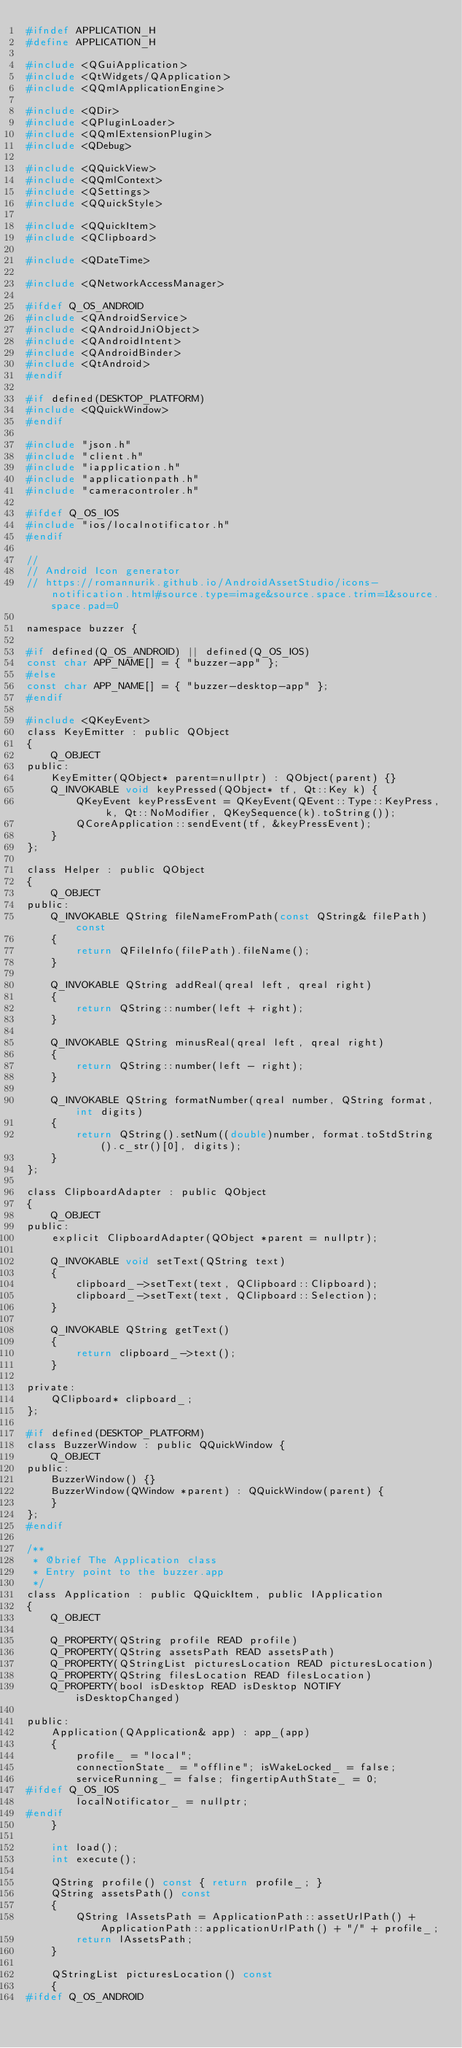<code> <loc_0><loc_0><loc_500><loc_500><_C_>#ifndef APPLICATION_H
#define APPLICATION_H

#include <QGuiApplication>
#include <QtWidgets/QApplication>
#include <QQmlApplicationEngine>

#include <QDir>
#include <QPluginLoader>
#include <QQmlExtensionPlugin>
#include <QDebug>

#include <QQuickView>
#include <QQmlContext>
#include <QSettings>
#include <QQuickStyle>

#include <QQuickItem>
#include <QClipboard>

#include <QDateTime>

#include <QNetworkAccessManager>

#ifdef Q_OS_ANDROID
#include <QAndroidService>
#include <QAndroidJniObject>
#include <QAndroidIntent>
#include <QAndroidBinder>
#include <QtAndroid>
#endif

#if defined(DESKTOP_PLATFORM)
#include <QQuickWindow>
#endif

#include "json.h"
#include "client.h"
#include "iapplication.h"
#include "applicationpath.h"
#include "cameracontroler.h"

#ifdef Q_OS_IOS
#include "ios/localnotificator.h"
#endif

//
// Android Icon generator
// https://romannurik.github.io/AndroidAssetStudio/icons-notification.html#source.type=image&source.space.trim=1&source.space.pad=0

namespace buzzer {

#if defined(Q_OS_ANDROID) || defined(Q_OS_IOS)
const char APP_NAME[] = { "buzzer-app" };
#else
const char APP_NAME[] = { "buzzer-desktop-app" };
#endif

#include <QKeyEvent>
class KeyEmitter : public QObject
{
	Q_OBJECT
public:
	KeyEmitter(QObject* parent=nullptr) : QObject(parent) {}
	Q_INVOKABLE void keyPressed(QObject* tf, Qt::Key k) {
		QKeyEvent keyPressEvent = QKeyEvent(QEvent::Type::KeyPress, k, Qt::NoModifier, QKeySequence(k).toString());
		QCoreApplication::sendEvent(tf, &keyPressEvent);
	}
};

class Helper : public QObject
{
    Q_OBJECT
public:
    Q_INVOKABLE QString fileNameFromPath(const QString& filePath) const
    {
        return QFileInfo(filePath).fileName();
    }

    Q_INVOKABLE QString addReal(qreal left, qreal right)
    {
        return QString::number(left + right);
    }

    Q_INVOKABLE QString minusReal(qreal left, qreal right)
    {
        return QString::number(left - right);
    }

    Q_INVOKABLE QString formatNumber(qreal number, QString format, int digits)
    {
        return QString().setNum((double)number, format.toStdString().c_str()[0], digits);
    }
};

class ClipboardAdapter : public QObject
{
    Q_OBJECT
public:
	explicit ClipboardAdapter(QObject *parent = nullptr);

    Q_INVOKABLE void setText(QString text)
    {
        clipboard_->setText(text, QClipboard::Clipboard);
        clipboard_->setText(text, QClipboard::Selection);
    }

    Q_INVOKABLE QString getText()
    {
        return clipboard_->text();
    }

private:
    QClipboard* clipboard_;
};

#if defined(DESKTOP_PLATFORM)
class BuzzerWindow : public QQuickWindow {
	Q_OBJECT
public:
	BuzzerWindow() {}
	BuzzerWindow(QWindow *parent) : QQuickWindow(parent) {
	}
};
#endif

/**
 * @brief The Application class
 * Entry point to the buzzer.app
 */
class Application : public QQuickItem, public IApplication
{
    Q_OBJECT

    Q_PROPERTY(QString profile READ profile)
    Q_PROPERTY(QString assetsPath READ assetsPath)
	Q_PROPERTY(QStringList picturesLocation READ picturesLocation)
	Q_PROPERTY(QString filesLocation READ filesLocation)
	Q_PROPERTY(bool isDesktop READ isDesktop NOTIFY isDesktopChanged)

public:
    Application(QApplication& app) : app_(app)
    {
		profile_ = "local";
        connectionState_ = "offline"; isWakeLocked_ = false;
        serviceRunning_ = false; fingertipAuthState_ = 0;
#ifdef Q_OS_IOS
        localNotificator_ = nullptr;
#endif
    }

    int load();
    int execute();

    QString profile() const { return profile_; }
    QString assetsPath() const
    {
        QString lAssetsPath = ApplicationPath::assetUrlPath() + ApplicationPath::applicationUrlPath() + "/" + profile_;
        return lAssetsPath;
    }

    QStringList picturesLocation() const
    {
#ifdef Q_OS_ANDROID</code> 